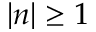<formula> <loc_0><loc_0><loc_500><loc_500>| n | \geq 1</formula> 